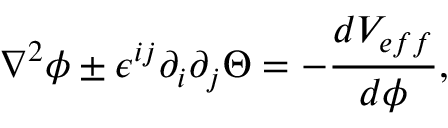<formula> <loc_0><loc_0><loc_500><loc_500>\nabla ^ { 2 } \phi \pm \epsilon ^ { i j } \partial _ { i } \partial _ { j } \Theta = - \frac { d V _ { e f f } } { d \phi } ,</formula> 